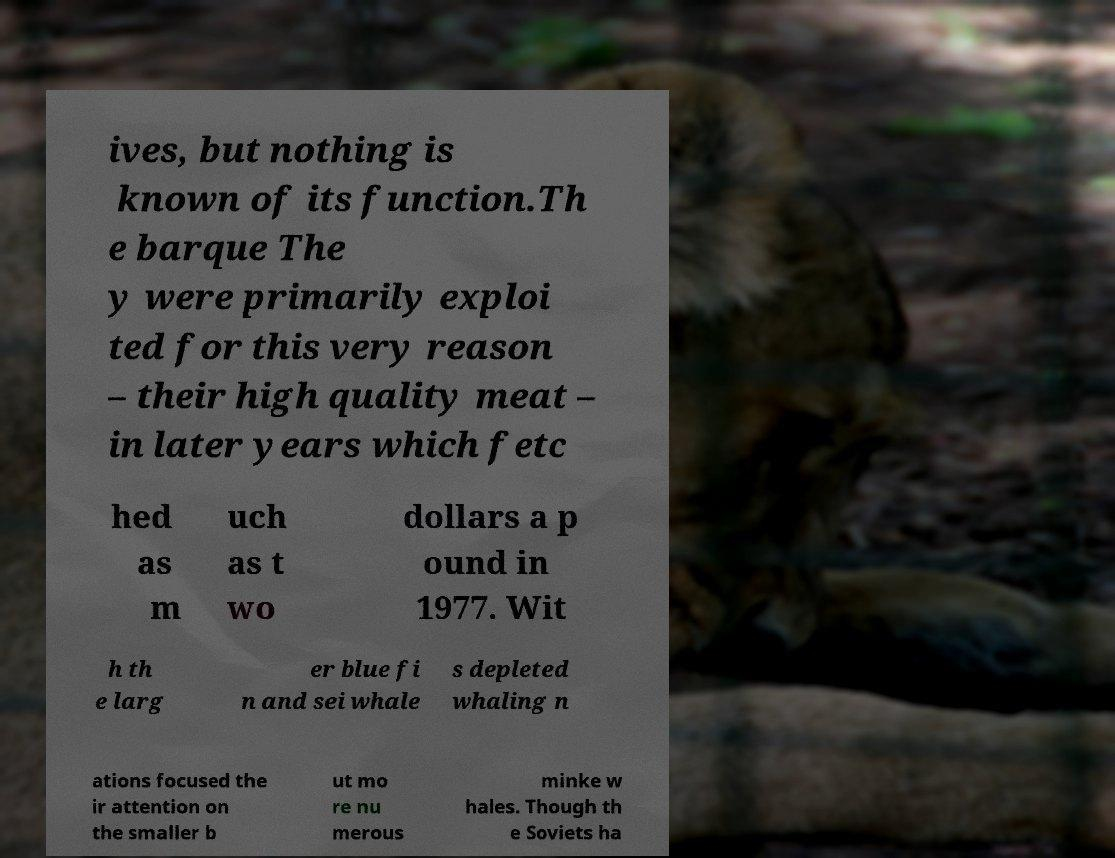Could you extract and type out the text from this image? ives, but nothing is known of its function.Th e barque The y were primarily exploi ted for this very reason – their high quality meat – in later years which fetc hed as m uch as t wo dollars a p ound in 1977. Wit h th e larg er blue fi n and sei whale s depleted whaling n ations focused the ir attention on the smaller b ut mo re nu merous minke w hales. Though th e Soviets ha 